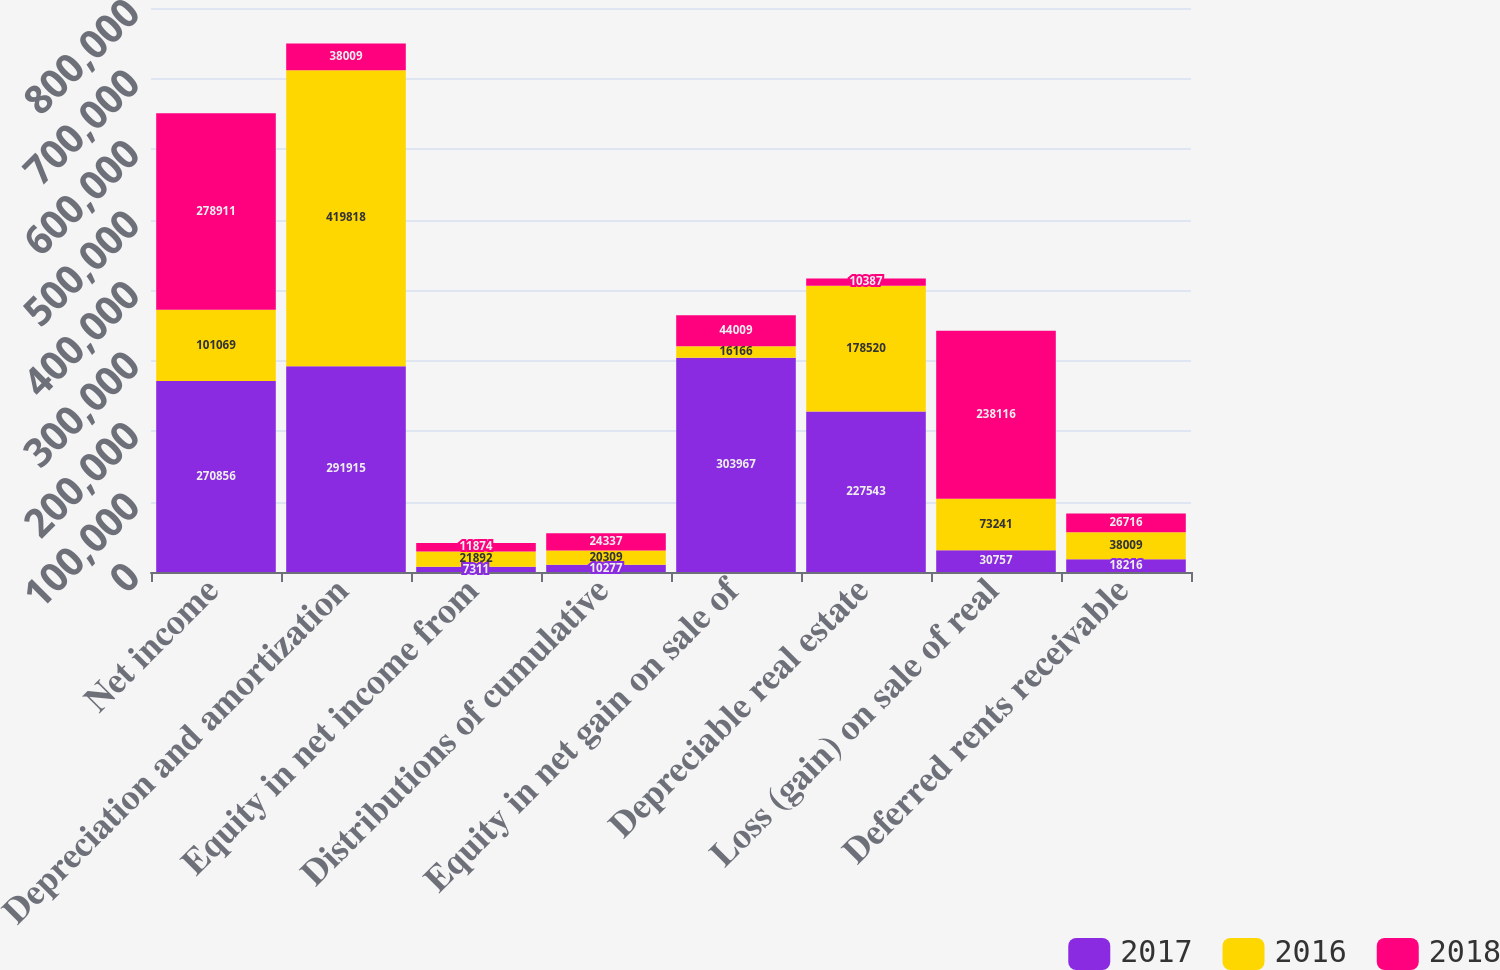Convert chart to OTSL. <chart><loc_0><loc_0><loc_500><loc_500><stacked_bar_chart><ecel><fcel>Net income<fcel>Depreciation and amortization<fcel>Equity in net income from<fcel>Distributions of cumulative<fcel>Equity in net gain on sale of<fcel>Depreciable real estate<fcel>Loss (gain) on sale of real<fcel>Deferred rents receivable<nl><fcel>2017<fcel>270856<fcel>291915<fcel>7311<fcel>10277<fcel>303967<fcel>227543<fcel>30757<fcel>18216<nl><fcel>2016<fcel>101069<fcel>419818<fcel>21892<fcel>20309<fcel>16166<fcel>178520<fcel>73241<fcel>38009<nl><fcel>2018<fcel>278911<fcel>38009<fcel>11874<fcel>24337<fcel>44009<fcel>10387<fcel>238116<fcel>26716<nl></chart> 